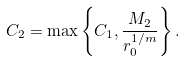<formula> <loc_0><loc_0><loc_500><loc_500>C _ { 2 } = \max \left \{ C _ { 1 } , \frac { M _ { 2 } } { r _ { 0 } ^ { 1 / m } } \right \} .</formula> 